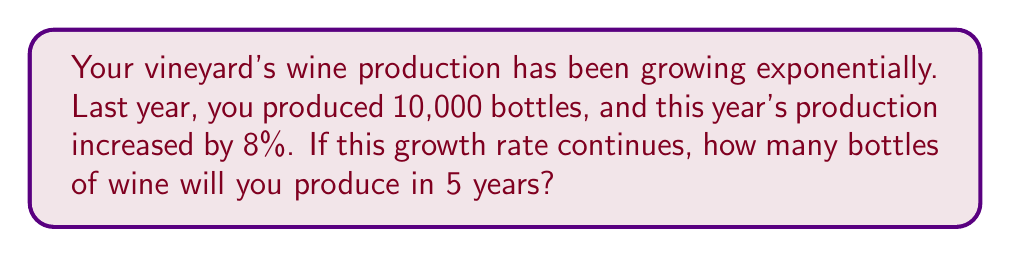Solve this math problem. Let's approach this step-by-step using an exponential growth model:

1) The exponential growth formula is:
   $$A = P(1 + r)^t$$
   Where:
   $A$ = Final amount
   $P$ = Initial amount
   $r$ = Growth rate (as a decimal)
   $t$ = Time period

2) We know:
   $P = 10,000$ bottles (initial production)
   $r = 0.08$ (8% growth rate)
   $t = 5$ years

3) Plugging these values into the formula:
   $$A = 10,000(1 + 0.08)^5$$

4) Simplify inside the parentheses:
   $$A = 10,000(1.08)^5$$

5) Calculate $(1.08)^5$:
   $$(1.08)^5 \approx 1.4693280768$$

6) Multiply by 10,000:
   $$A \approx 10,000 \times 1.4693280768 = 14,693.280768$$

7) Round to the nearest whole number (as we can't produce partial bottles):
   $$A \approx 14,693$$ bottles

Therefore, in 5 years, you will produce approximately 14,693 bottles of wine if the 8% growth rate continues.
Answer: 14,693 bottles 